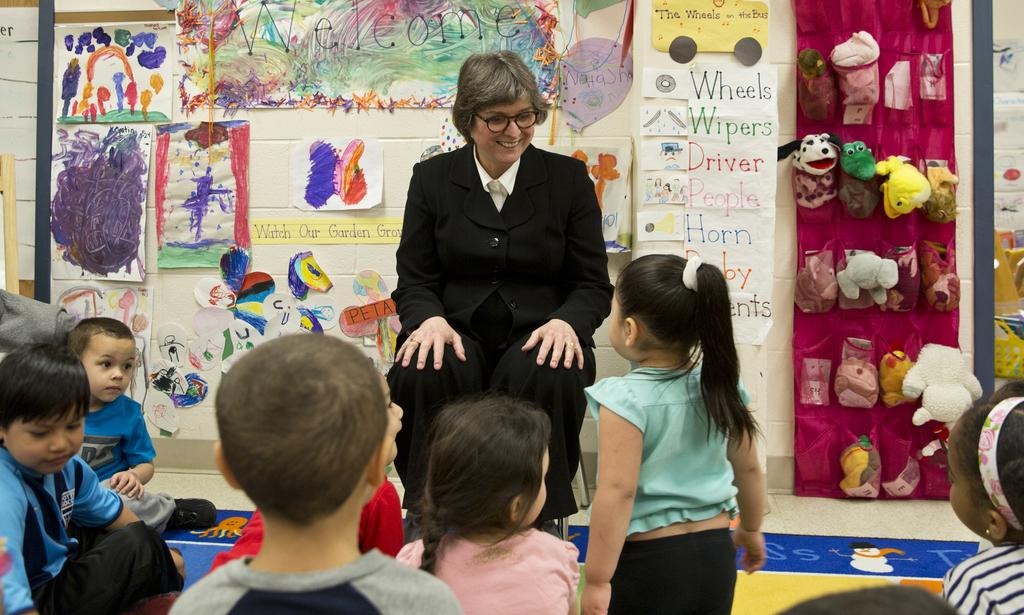What is the woman in the image doing? The woman is sitting on a chair in the image. What can be seen at the bottom of the image? There are children at the bottom of the image. What is present on the wall in the background of the image? There are papers and toys on the wall in the background of the image. What type of pail is being used to burn the papers on the wall in the image? There is no pail or burning activity present in the image. 